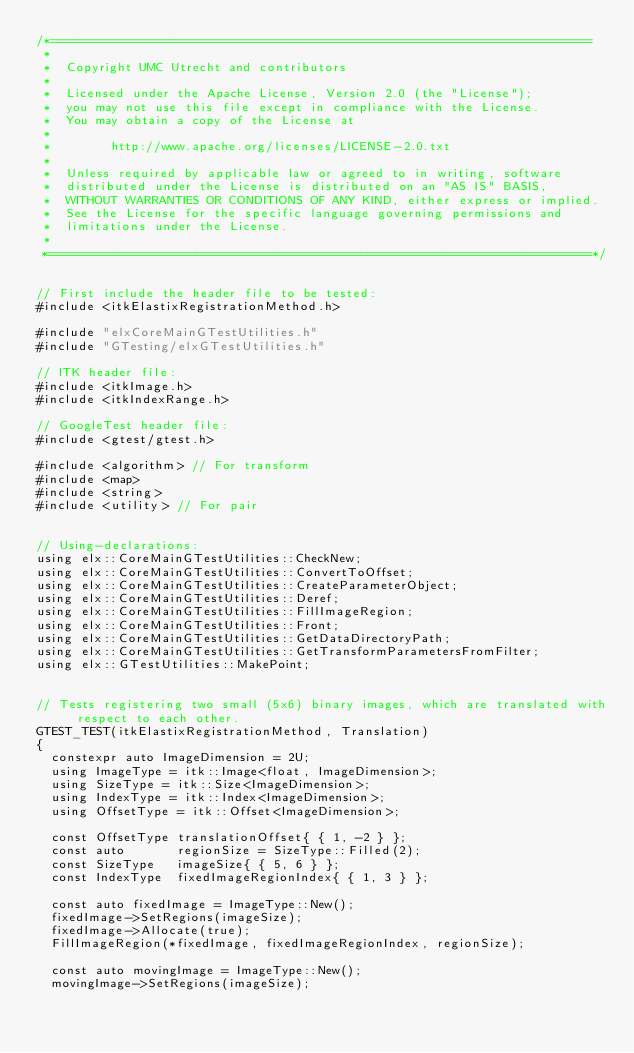<code> <loc_0><loc_0><loc_500><loc_500><_C++_>/*=========================================================================
 *
 *  Copyright UMC Utrecht and contributors
 *
 *  Licensed under the Apache License, Version 2.0 (the "License");
 *  you may not use this file except in compliance with the License.
 *  You may obtain a copy of the License at
 *
 *        http://www.apache.org/licenses/LICENSE-2.0.txt
 *
 *  Unless required by applicable law or agreed to in writing, software
 *  distributed under the License is distributed on an "AS IS" BASIS,
 *  WITHOUT WARRANTIES OR CONDITIONS OF ANY KIND, either express or implied.
 *  See the License for the specific language governing permissions and
 *  limitations under the License.
 *
 *=========================================================================*/


// First include the header file to be tested:
#include <itkElastixRegistrationMethod.h>

#include "elxCoreMainGTestUtilities.h"
#include "GTesting/elxGTestUtilities.h"

// ITK header file:
#include <itkImage.h>
#include <itkIndexRange.h>

// GoogleTest header file:
#include <gtest/gtest.h>

#include <algorithm> // For transform
#include <map>
#include <string>
#include <utility> // For pair


// Using-declarations:
using elx::CoreMainGTestUtilities::CheckNew;
using elx::CoreMainGTestUtilities::ConvertToOffset;
using elx::CoreMainGTestUtilities::CreateParameterObject;
using elx::CoreMainGTestUtilities::Deref;
using elx::CoreMainGTestUtilities::FillImageRegion;
using elx::CoreMainGTestUtilities::Front;
using elx::CoreMainGTestUtilities::GetDataDirectoryPath;
using elx::CoreMainGTestUtilities::GetTransformParametersFromFilter;
using elx::GTestUtilities::MakePoint;


// Tests registering two small (5x6) binary images, which are translated with respect to each other.
GTEST_TEST(itkElastixRegistrationMethod, Translation)
{
  constexpr auto ImageDimension = 2U;
  using ImageType = itk::Image<float, ImageDimension>;
  using SizeType = itk::Size<ImageDimension>;
  using IndexType = itk::Index<ImageDimension>;
  using OffsetType = itk::Offset<ImageDimension>;

  const OffsetType translationOffset{ { 1, -2 } };
  const auto       regionSize = SizeType::Filled(2);
  const SizeType   imageSize{ { 5, 6 } };
  const IndexType  fixedImageRegionIndex{ { 1, 3 } };

  const auto fixedImage = ImageType::New();
  fixedImage->SetRegions(imageSize);
  fixedImage->Allocate(true);
  FillImageRegion(*fixedImage, fixedImageRegionIndex, regionSize);

  const auto movingImage = ImageType::New();
  movingImage->SetRegions(imageSize);</code> 